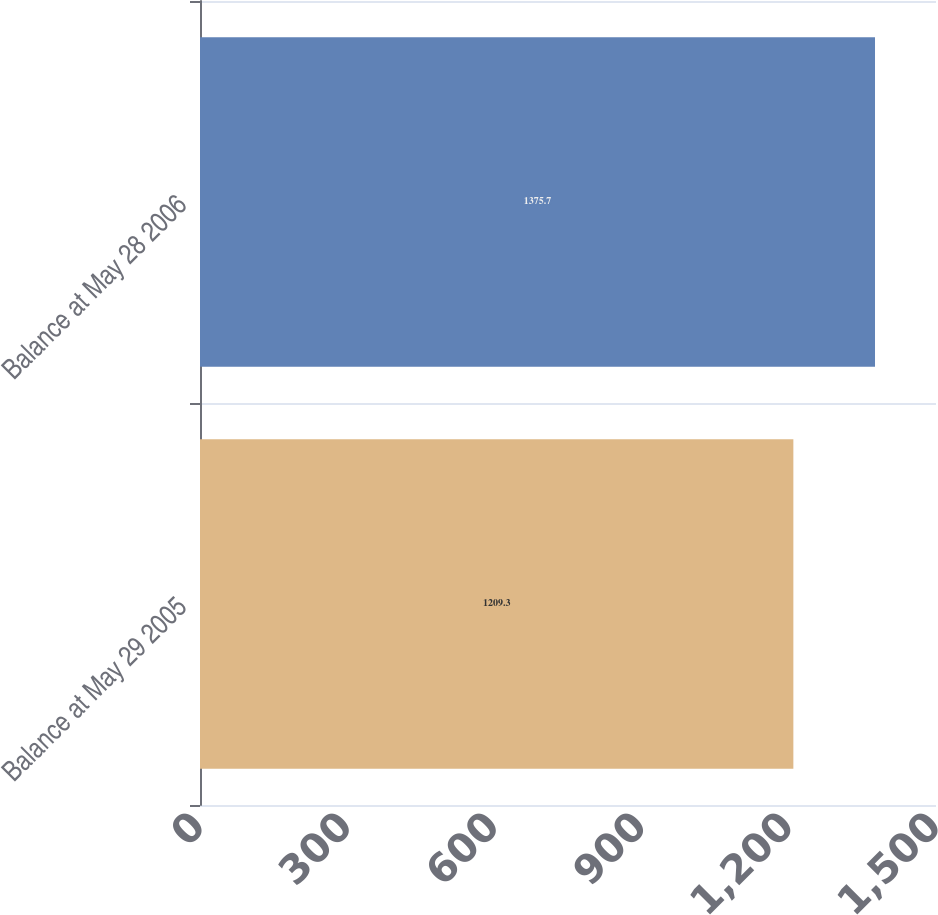Convert chart. <chart><loc_0><loc_0><loc_500><loc_500><bar_chart><fcel>Balance at May 29 2005<fcel>Balance at May 28 2006<nl><fcel>1209.3<fcel>1375.7<nl></chart> 